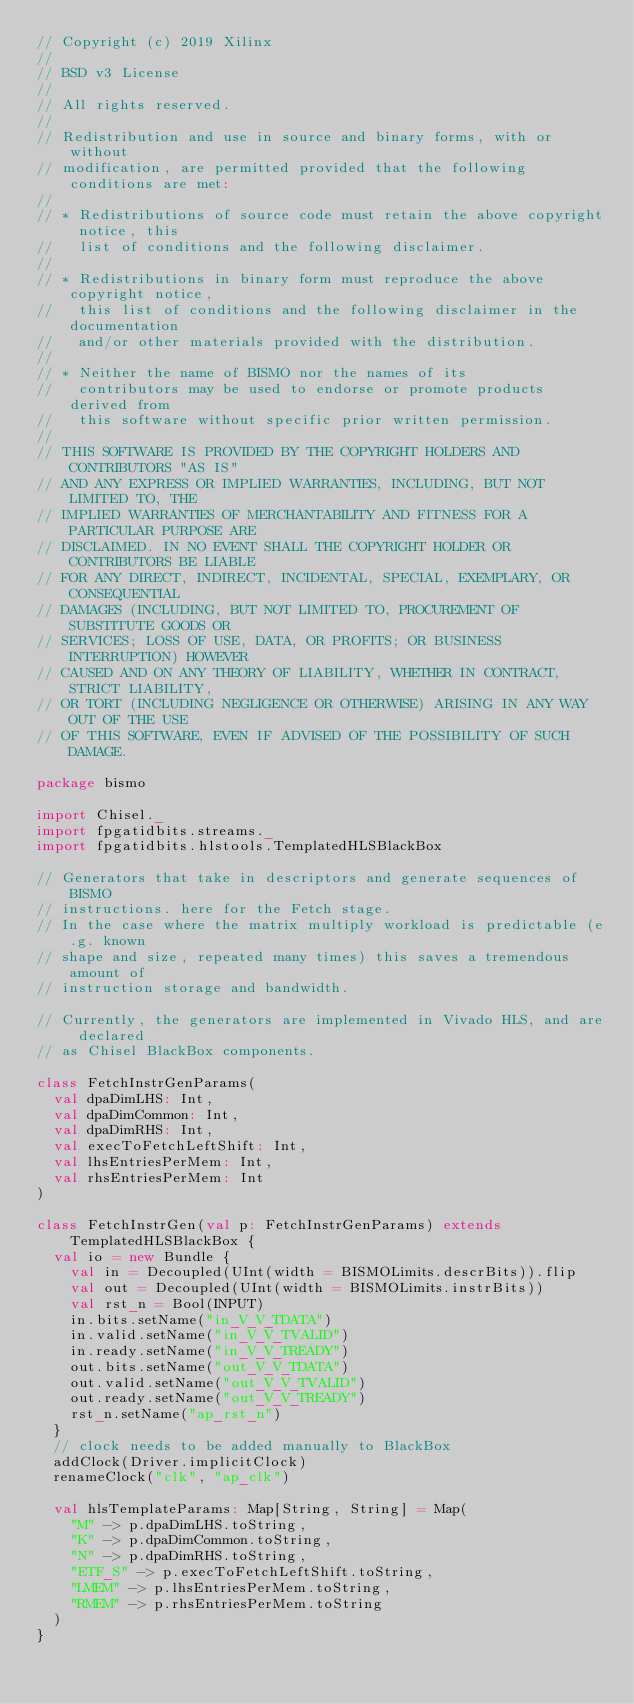Convert code to text. <code><loc_0><loc_0><loc_500><loc_500><_Scala_>// Copyright (c) 2019 Xilinx
//
// BSD v3 License
//
// All rights reserved.
//
// Redistribution and use in source and binary forms, with or without
// modification, are permitted provided that the following conditions are met:
//
// * Redistributions of source code must retain the above copyright notice, this
//   list of conditions and the following disclaimer.
//
// * Redistributions in binary form must reproduce the above copyright notice,
//   this list of conditions and the following disclaimer in the documentation
//   and/or other materials provided with the distribution.
//
// * Neither the name of BISMO nor the names of its
//   contributors may be used to endorse or promote products derived from
//   this software without specific prior written permission.
//
// THIS SOFTWARE IS PROVIDED BY THE COPYRIGHT HOLDERS AND CONTRIBUTORS "AS IS"
// AND ANY EXPRESS OR IMPLIED WARRANTIES, INCLUDING, BUT NOT LIMITED TO, THE
// IMPLIED WARRANTIES OF MERCHANTABILITY AND FITNESS FOR A PARTICULAR PURPOSE ARE
// DISCLAIMED. IN NO EVENT SHALL THE COPYRIGHT HOLDER OR CONTRIBUTORS BE LIABLE
// FOR ANY DIRECT, INDIRECT, INCIDENTAL, SPECIAL, EXEMPLARY, OR CONSEQUENTIAL
// DAMAGES (INCLUDING, BUT NOT LIMITED TO, PROCUREMENT OF SUBSTITUTE GOODS OR
// SERVICES; LOSS OF USE, DATA, OR PROFITS; OR BUSINESS INTERRUPTION) HOWEVER
// CAUSED AND ON ANY THEORY OF LIABILITY, WHETHER IN CONTRACT, STRICT LIABILITY,
// OR TORT (INCLUDING NEGLIGENCE OR OTHERWISE) ARISING IN ANY WAY OUT OF THE USE
// OF THIS SOFTWARE, EVEN IF ADVISED OF THE POSSIBILITY OF SUCH DAMAGE.

package bismo

import Chisel._
import fpgatidbits.streams._
import fpgatidbits.hlstools.TemplatedHLSBlackBox

// Generators that take in descriptors and generate sequences of BISMO
// instructions. here for the Fetch stage.
// In the case where the matrix multiply workload is predictable (e.g. known
// shape and size, repeated many times) this saves a tremendous amount of
// instruction storage and bandwidth.

// Currently, the generators are implemented in Vivado HLS, and are declared
// as Chisel BlackBox components.

class FetchInstrGenParams(
  val dpaDimLHS: Int,
  val dpaDimCommon: Int,
  val dpaDimRHS: Int,
  val execToFetchLeftShift: Int,
  val lhsEntriesPerMem: Int,
  val rhsEntriesPerMem: Int
)

class FetchInstrGen(val p: FetchInstrGenParams) extends TemplatedHLSBlackBox {
  val io = new Bundle {
    val in = Decoupled(UInt(width = BISMOLimits.descrBits)).flip
    val out = Decoupled(UInt(width = BISMOLimits.instrBits))
    val rst_n = Bool(INPUT)
    in.bits.setName("in_V_V_TDATA")
    in.valid.setName("in_V_V_TVALID")
    in.ready.setName("in_V_V_TREADY")
    out.bits.setName("out_V_V_TDATA")
    out.valid.setName("out_V_V_TVALID")
    out.ready.setName("out_V_V_TREADY")
    rst_n.setName("ap_rst_n")
  }
  // clock needs to be added manually to BlackBox
	addClock(Driver.implicitClock)
  renameClock("clk", "ap_clk")

  val hlsTemplateParams: Map[String, String] = Map(
    "M" -> p.dpaDimLHS.toString,
    "K" -> p.dpaDimCommon.toString,
    "N" -> p.dpaDimRHS.toString,
    "ETF_S" -> p.execToFetchLeftShift.toString,
    "LMEM" -> p.lhsEntriesPerMem.toString,
    "RMEM" -> p.rhsEntriesPerMem.toString
  )
}
</code> 